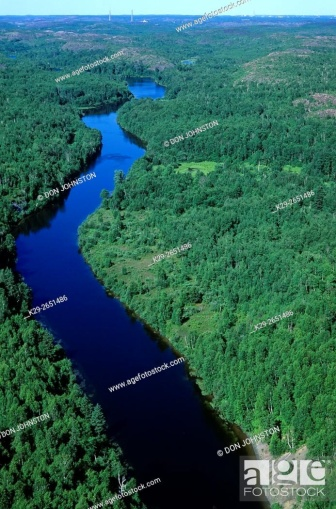What type of activities could this river be used for, taking into consideration the terrain and natural setting? The river's winding path through a forested landscape suggests it could be ideal for recreational activities like kayaking, canoeing, and fishing. The calm and secluded nature also makes it a potential site for bird watching and wildlife photography. Given the apparent lack of nearby civilization, it's unlikely that the river sees frequent or heavy use for commercial or industrial activities. 